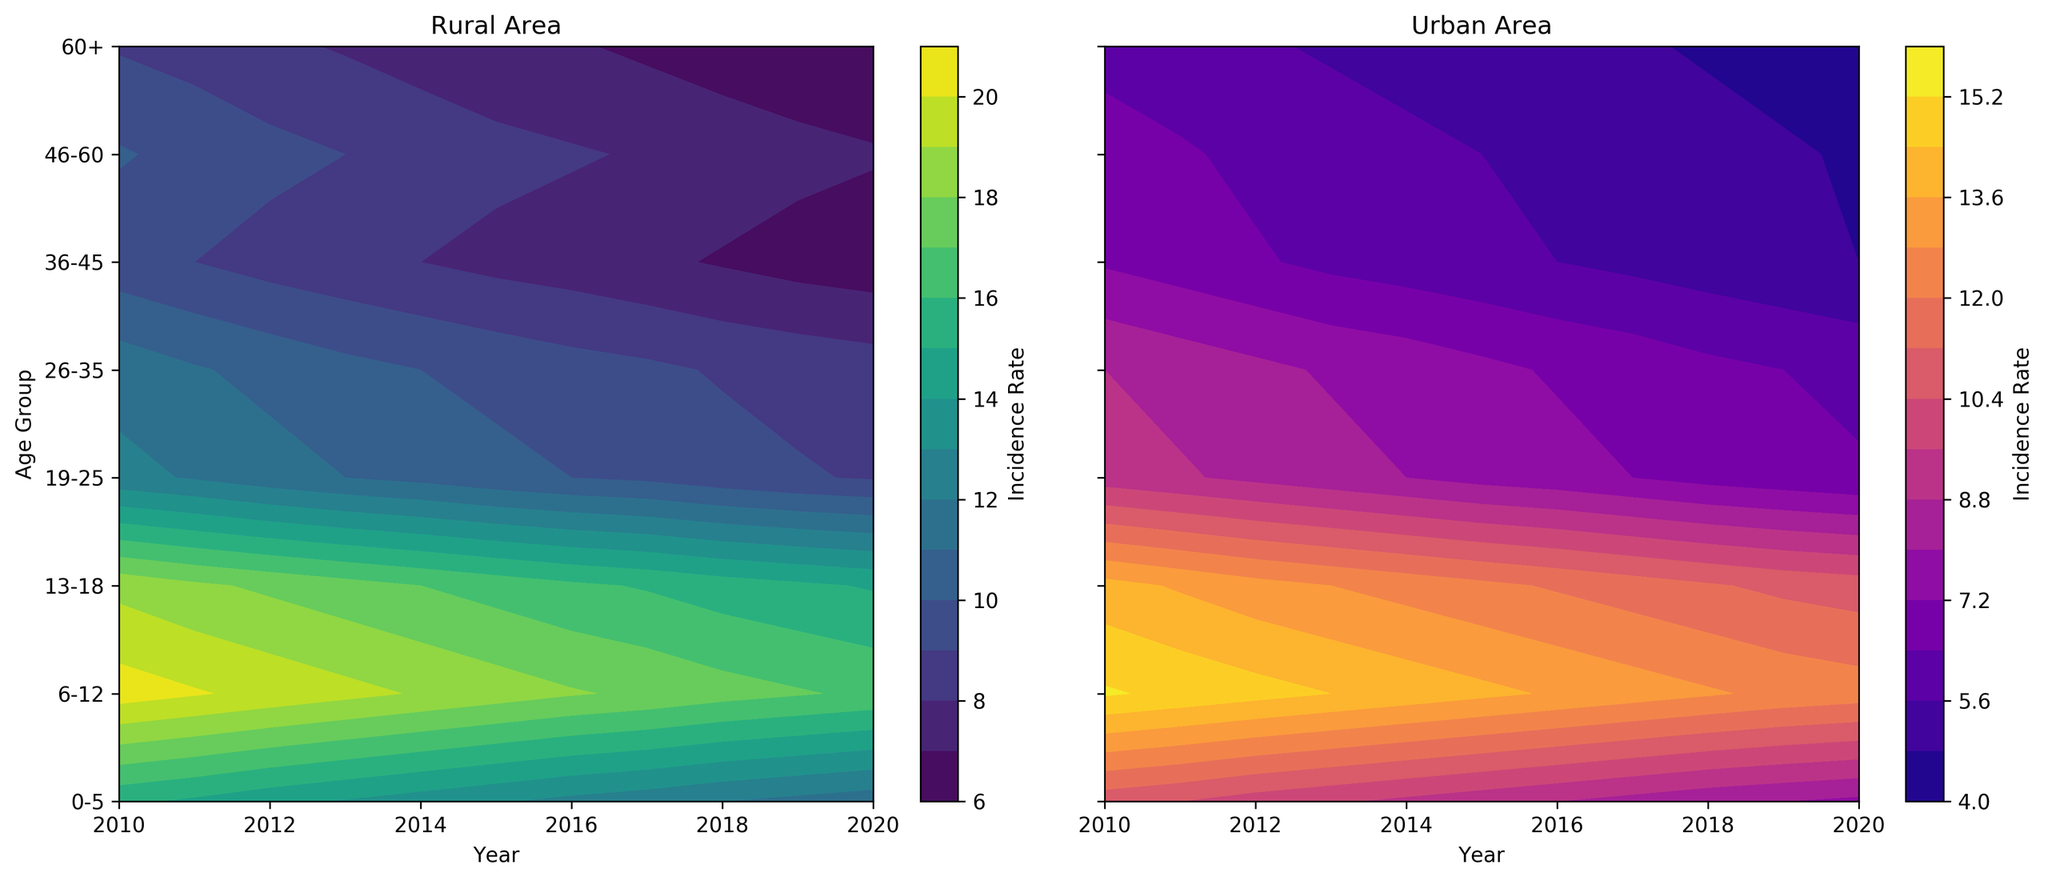What is the trend in disease incidence rates for the age group 0-5 in rural areas from 2010 to 2020? Observe the left contour plot for rural areas and follow the color contours for the age group 0-5 along the x-axis (years from 2010 to 2020). The colors appear to shift from a darker tone to a lighter tone over the years, indicating a decrease in incidence rates.
Answer: Decreasing Which age group has the lowest disease incidence rate in urban areas in 2020? Look at the right contour plot for urban areas and locate the year 2020 on the x-axis. The age group 60+ shows the darkest color, corresponding to the lowest incidence rate.
Answer: 60+ Compare the disease incidence rate of the age group 19-25 in urban areas in 2010 with that of the same age group in rural areas in 2010. Which is greater? Check the right contour plot for urban areas and find the value for the 19-25 age group in 2010. It is dark in color. Then, check the left contour plot for rural areas; it shows a lighter color, indicating a higher incidence rate. Thus, the rate in rural areas is greater.
Answer: Rural What visual trend do you observe for the age group 6-12 in rural and urban areas from 2010 to 2020? In both contour plots, trace the color patterns for the age group 6-12. In rural areas, the colors gradually become lighter, indicating a decline, while in urban areas, the change is also to lighter colors but slightly less pronounced.
Answer: Declining in both Which year has the lowest overall disease incidence rate for rural areas, and how do you know? In the left contour plot for rural areas, find the lightest color on the contour plot, which indicates the lowest incidence rates. This lightest shade appears consistently around 2020.
Answer: 2020 What is the difference in disease incidence rate for the age group 36-45 between rural and urban areas in 2015? Identify the color for the age group 36-45 in 2015 on both contour plots. In rural areas, it’s around 7.7, corresponding to a medium shade, while in urban areas, it is around 5.8, which is a slightly lighter shade. The difference is 7.7 - 5.8 = 1.9.
Answer: 1.9 Which age group in rural areas saw the most significant decline in disease incidence rate from 2010 to 2020? Compare the colors for each age group from 2010 to 2020 on the left contour plot. The age group 0-5 shows the most significant change from dark to light color, indicating the largest decline.
Answer: 0-5 Between urban and rural areas, for which year does the age group 19-25 have a more significant difference in disease incidence rate? Identify the more considerable difference. For the age group 19-25, compare the colors in both contour plots year by year. The difference is most noticeable in 2010, as rural areas are notably lighter than urban areas.
Answer: 2010 How does the disease incidence rate for the age group 60+ change in urban areas from 2010 to 2020? Examine the right contour plot for urban areas and focus on the age group 60+ along the x-axis. The color changes from a darker to a lighter shade gradually, indicating a decrease over time.
Answer: Decreasing 